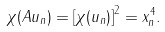Convert formula to latex. <formula><loc_0><loc_0><loc_500><loc_500>\chi ( A u _ { n } ) = \left [ \chi ( u _ { n } ) \right ] ^ { 2 } = x _ { n } ^ { 4 } .</formula> 